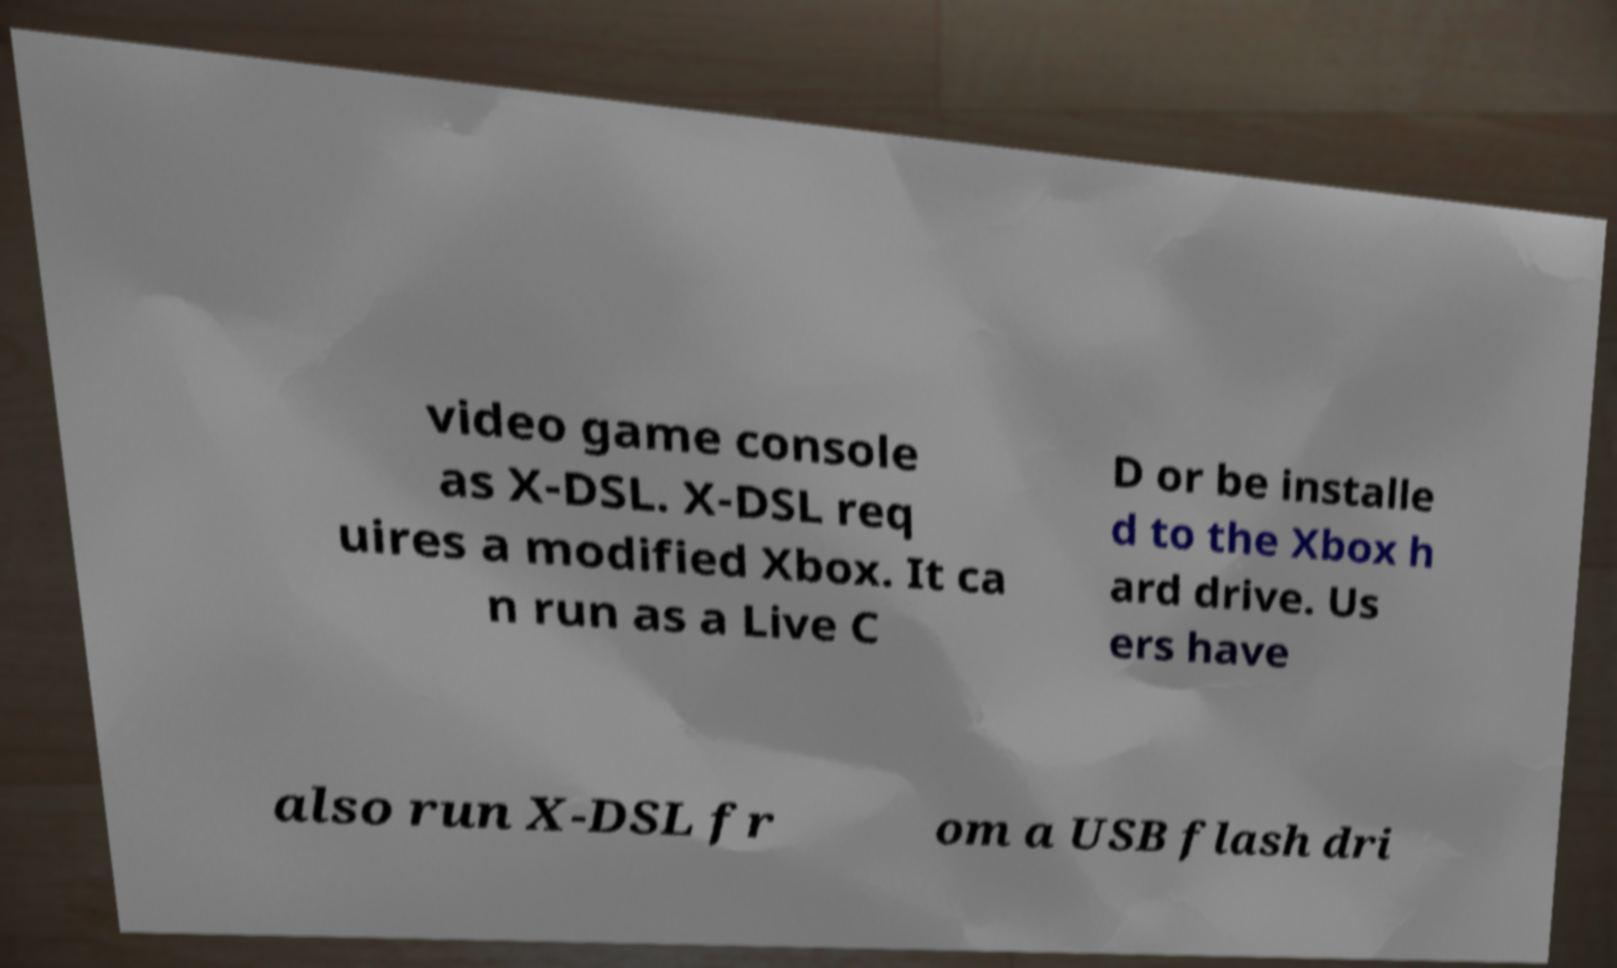Could you assist in decoding the text presented in this image and type it out clearly? video game console as X-DSL. X-DSL req uires a modified Xbox. It ca n run as a Live C D or be installe d to the Xbox h ard drive. Us ers have also run X-DSL fr om a USB flash dri 